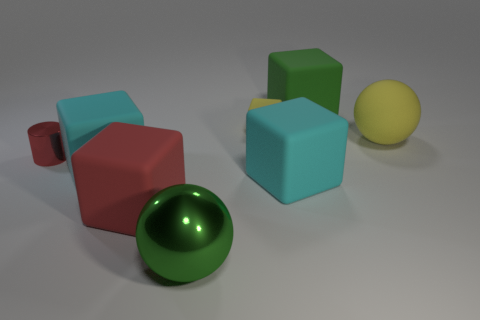How many other things are the same color as the tiny matte object?
Give a very brief answer. 1. There is a tiny block that is the same material as the big green cube; what color is it?
Ensure brevity in your answer.  Yellow. There is another sphere that is the same size as the green metallic ball; what color is it?
Your answer should be very brief. Yellow. Are there any other things that are the same color as the shiny sphere?
Ensure brevity in your answer.  Yes. Is the material of the large block that is behind the tiny matte block the same as the big yellow thing?
Make the answer very short. Yes. What number of green objects are in front of the yellow rubber cube and behind the green shiny sphere?
Provide a succinct answer. 0. There is a rubber ball behind the large thing in front of the large red matte block; how big is it?
Provide a short and direct response. Large. Is there anything else that has the same material as the cylinder?
Give a very brief answer. Yes. Are there more tiny red metallic things than large red shiny spheres?
Keep it short and to the point. Yes. Do the tiny thing that is behind the cylinder and the big cube that is behind the tiny red cylinder have the same color?
Make the answer very short. No. 